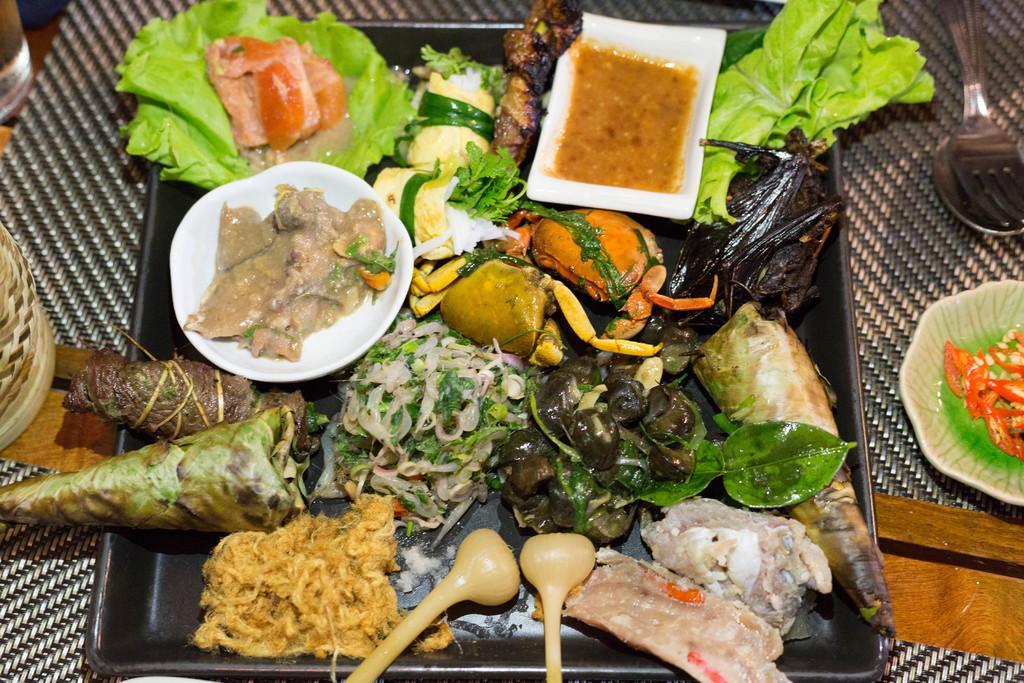Can you describe this image briefly? In the picture we can see some food item which is in tray and we can see spoon and fork which is on table. 